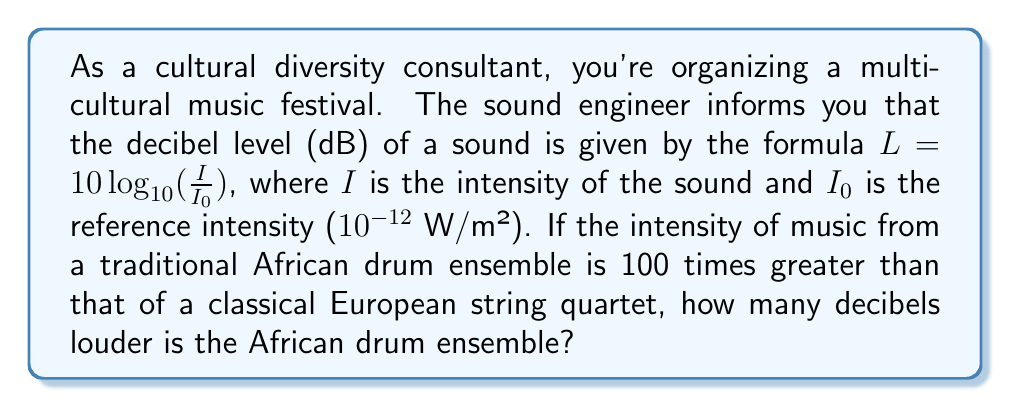What is the answer to this math problem? Let's approach this step-by-step:

1) We're given that the intensity of the African drum ensemble $(I_A)$ is 100 times greater than that of the European string quartet $(I_E)$. We can express this as:

   $I_A = 100 I_E$

2) The decibel level for each performance is given by:

   $L_A = 10 \log_{10} (\frac{I_A}{I_0})$ for the African drums
   $L_E = 10 \log_{10} (\frac{I_E}{I_0})$ for the European quartet

3) The difference in decibel levels is:

   $L_A - L_E = 10 \log_{10} (\frac{I_A}{I_0}) - 10 \log_{10} (\frac{I_E}{I_0})$

4) Using the logarithm property $\log_a(x) - \log_a(y) = \log_a(\frac{x}{y})$, we get:

   $L_A - L_E = 10 \log_{10} (\frac{I_A}{I_E})$

5) We know that $I_A = 100 I_E$, so:

   $L_A - L_E = 10 \log_{10} (100)$

6) $\log_{10} (100) = 2$, so:

   $L_A - L_E = 10 \cdot 2 = 20$

Therefore, the African drum ensemble is 20 decibels louder than the European string quartet.
Answer: 20 dB 